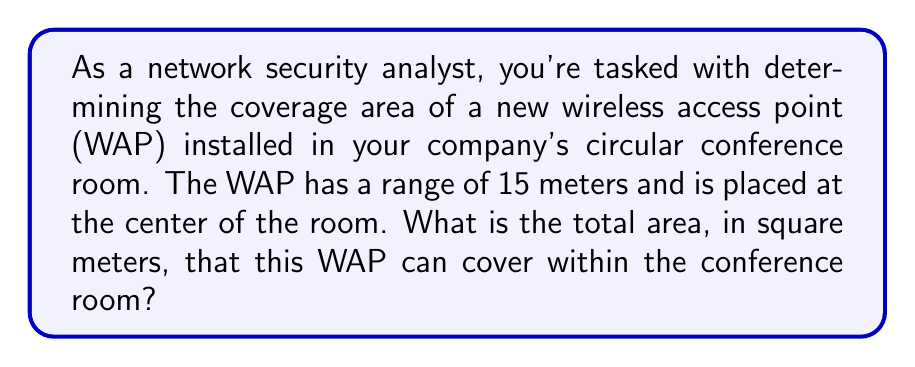Show me your answer to this math problem. To solve this problem, we need to follow these steps:

1) The coverage area of a WAP is typically circular, with the WAP at the center. The range of the WAP represents the radius of this circular area.

2) The formula for the area of a circle is:

   $$A = \pi r^2$$

   Where:
   $A$ = area
   $\pi$ (pi) ≈ 3.14159
   $r$ = radius

3) In this case, the radius is the range of the WAP, which is 15 meters.

4) Let's plug these values into our formula:

   $$A = \pi (15)^2$$

5) Simplify:
   $$A = \pi (225)$$

6) Calculate:
   $$A ≈ 3.14159 * 225 ≈ 706.86 \text{ m}^2$$

7) Round to two decimal places:
   $$A ≈ 706.86 \text{ m}^2$$

[asy]
import geometry;

size(200);
pair O = (0,0);
real r = 5;
draw(circle(O,r));
dot(O);
draw(O--(-r,0),arrow=Arrow(TeXHead));
label("15 m", (-r/2,0), S);
label("WAP", O, N);
[/asy]

This diagram illustrates the circular coverage area of the WAP.
Answer: The total area that the wireless access point can cover is approximately 706.86 square meters. 